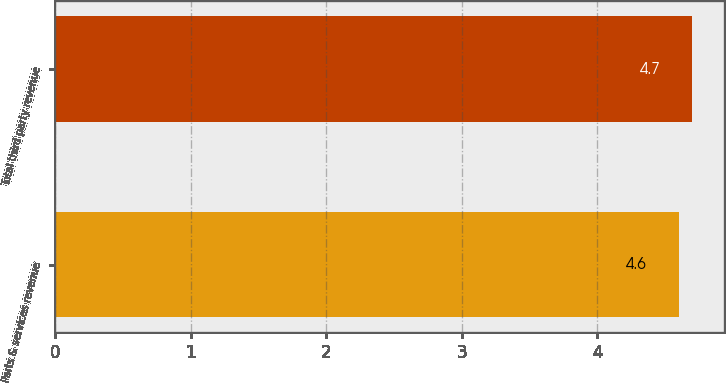<chart> <loc_0><loc_0><loc_500><loc_500><bar_chart><fcel>Parts & services revenue<fcel>Total third party revenue<nl><fcel>4.6<fcel>4.7<nl></chart> 